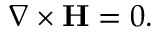<formula> <loc_0><loc_0><loc_500><loc_500>\nabla \times H = 0 .</formula> 